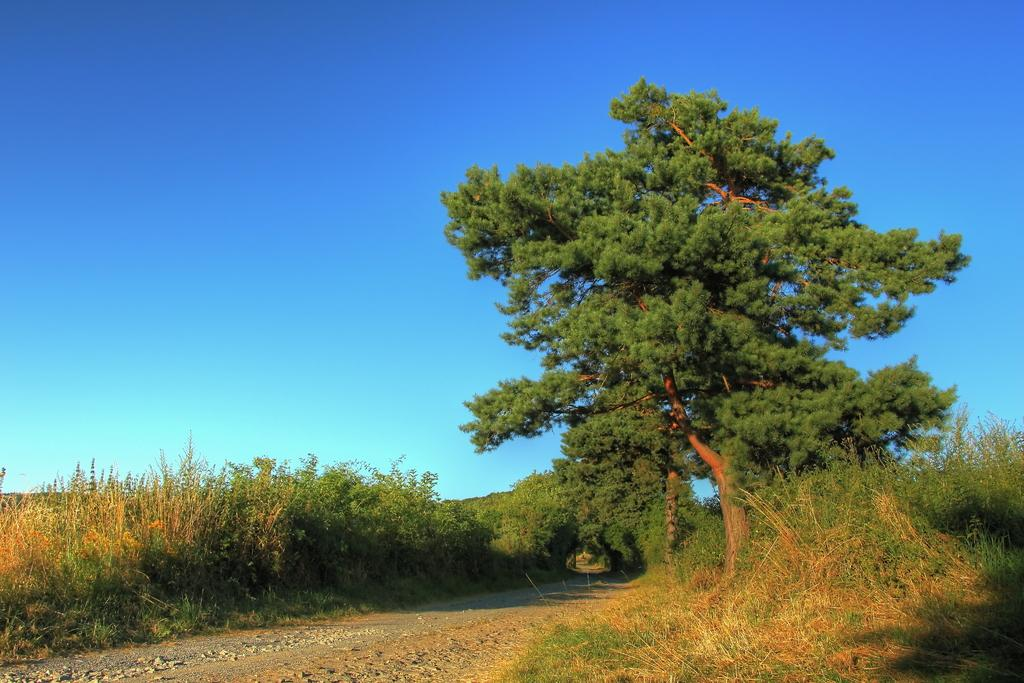What type of vegetation is present in the image? There are trees and plants in the image. Where are the trees and plants located? The trees and plants are on land with grass. What can be seen in the bottom left of the image? There is a road in the bottom left of the image. What is visible at the top of the image? The sky is visible at the top of the image. How many bubbles are floating in the sky in the image? There are no bubbles present in the image; the sky is visible without any bubbles. 